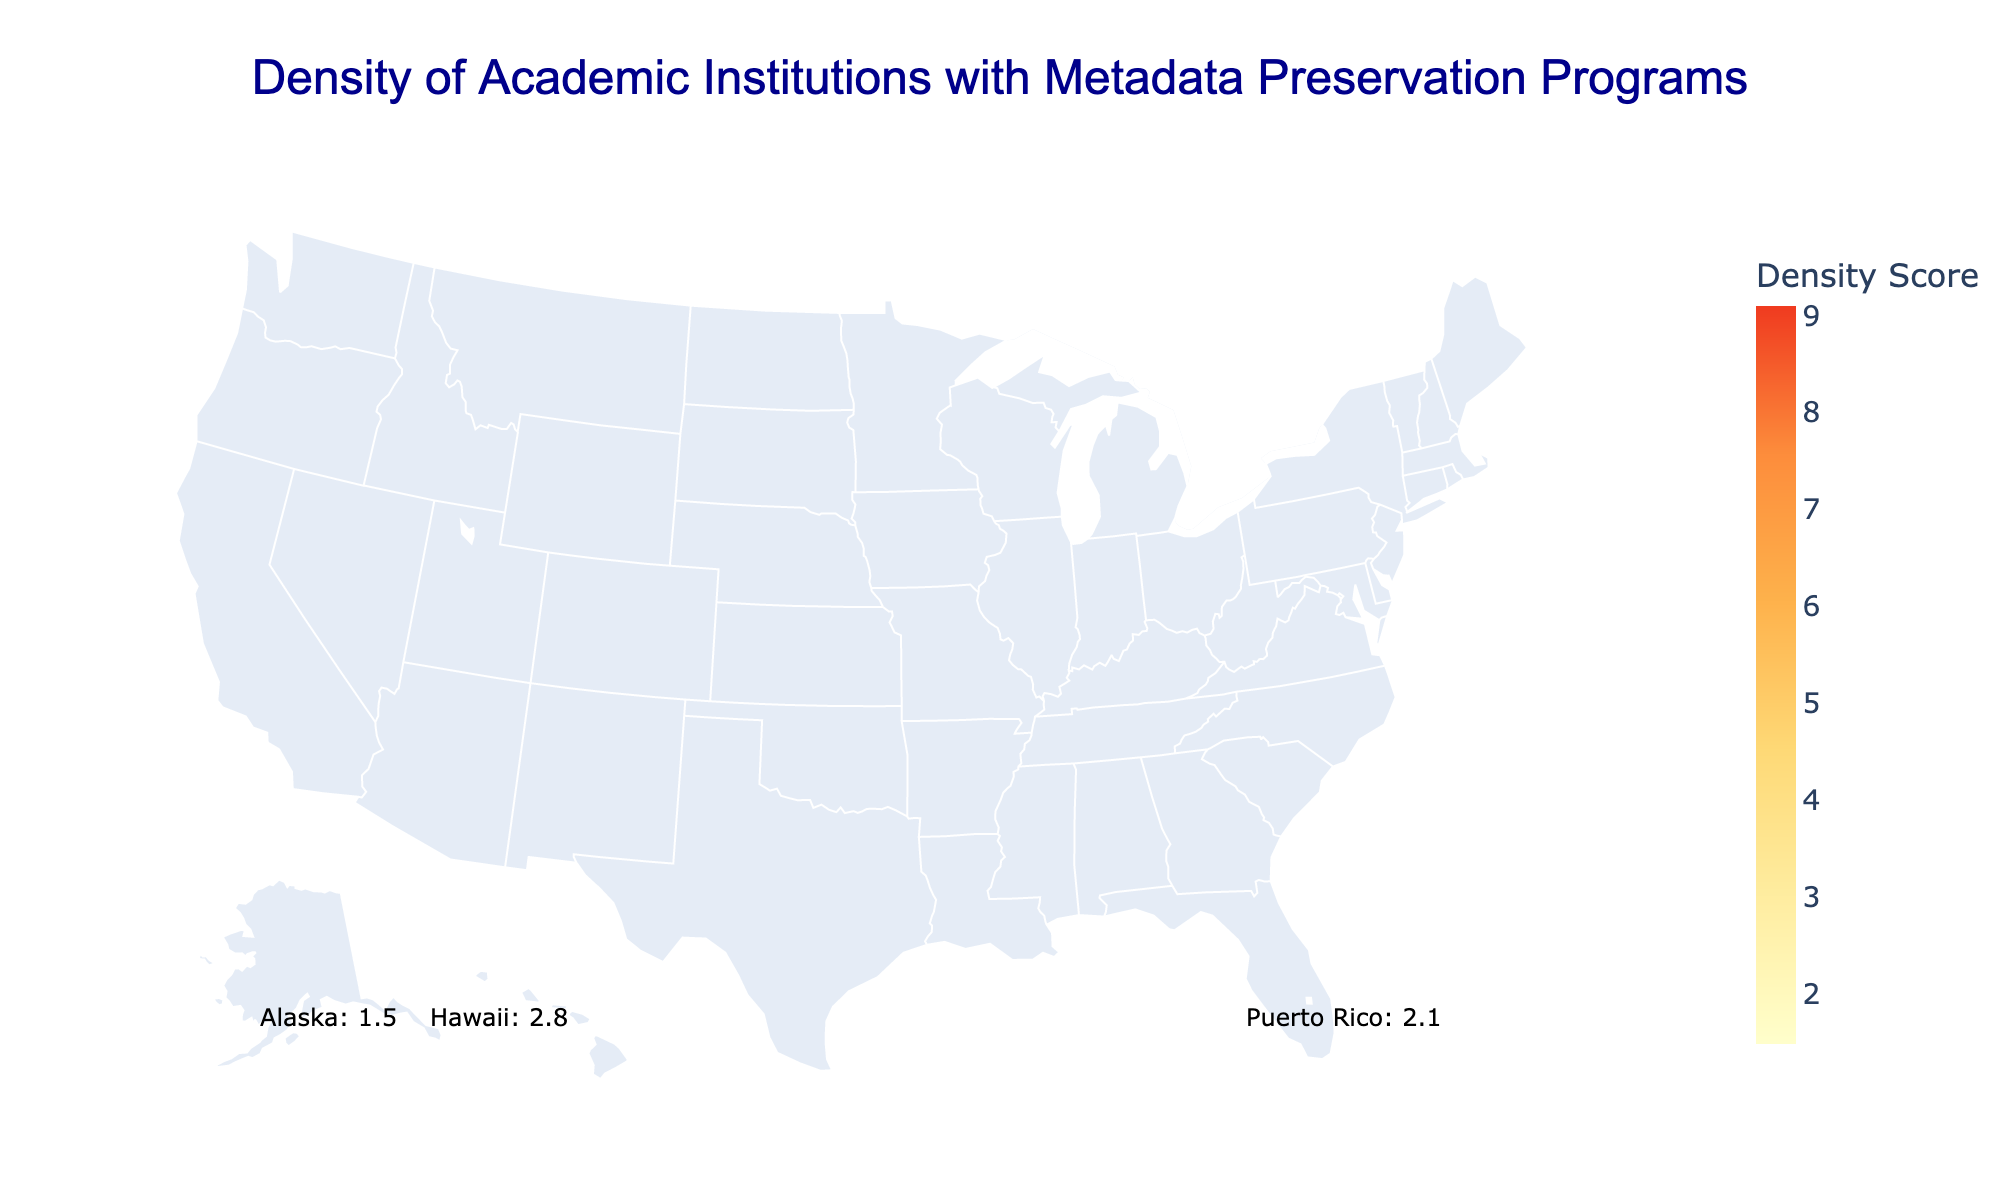What is the title of the map? The title of the map can be found at the top of the figure, it reads "Density of Academic Institutions with Metadata Preservation Programs."
Answer: Density of Academic Institutions with Metadata Preservation Programs Which region has the highest density score? By examining the color codes and the hover information, the region with the darkest color representing the highest density score is the West Coast.
Answer: West Coast How many institutions in the Mid-Atlantic region have metadata preservation programs? The hover text or data points show the number of institutions for each region, and for the Mid-Atlantic region, it displays 22 institutions.
Answer: 22 institutions Compare the density scores of New England and the Midwest. Which has a higher density score and by how much? First, identify the density scores for both regions from the hover info: New England has 8.2 and Midwest has 6.8. Subtract 6.8 from 8.2 to find the difference.
Answer: New England has a higher density score by 1.4 What is the combined number of institutions in the Southeast and Southwest regions? The Southeast has 18 institutions and the Southwest has 9 institutions. Sum them: 18 + 9 = 27 institutions.
Answer: 27 institutions Which regions have a density score lower than 3? By checking the hover information, the regions with density scores lower than 3 are Alaska (1.5), Hawaii (2.8), and Puerto Rico (2.1).
Answer: Alaska, Hawaii, Puerto Rico What is the average density score of the West Coast, Rocky Mountains, and Alaska regions? The density scores for each region are: West Coast (9.1), Rocky Mountains (3.7), and Alaska (1.5). Calculate the average by adding these scores and dividing by the number of scores: (9.1 + 3.7 + 1.5) / 3 = 4.77.
Answer: 4.77 How does the number of institutions in Hawaii compare to Puerto Rico? According to the hover information, Hawaii has 2 institutions and Puerto Rico has 1 institution. Comparing these numbers, Hawaii has 1 more institution than Puerto Rico.
Answer: Hawaii has 1 more institution Is there a correlation between the density score and the number of institutions in each region? Generally, the regions with higher density scores tend to have more institutions, as seen with the West Coast having both the highest density score (9.1) and the highest number of institutions (25). More comprehensive analysis would be needed to confirm correlation, but a visual inspection suggests a positive correlation.
Answer: Suggests a positive correlation 